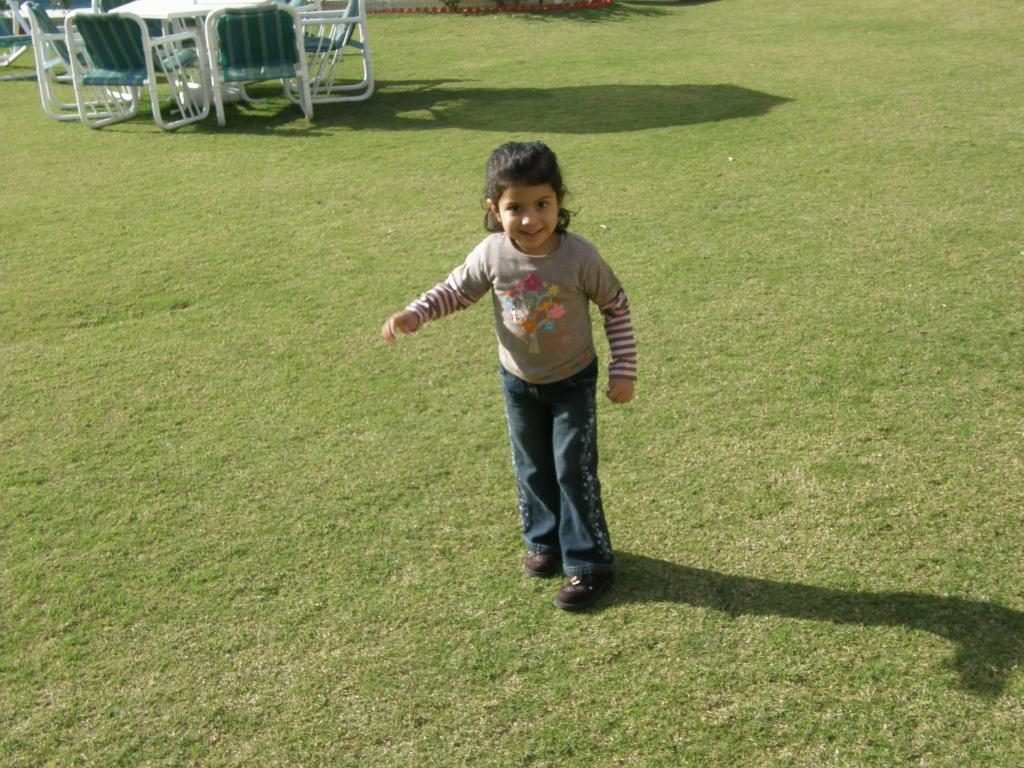What is the main subject of the image? There is a child in the image. Where is the child located? The child is standing on the grass. What is the child's expression? The child is smiling. What can be seen in the background of the image? There are chairs and a table in the background of the image. What type of lettuce is being used as a hat by the child in the image? There is no lettuce present in the image, and the child is not wearing a hat. 